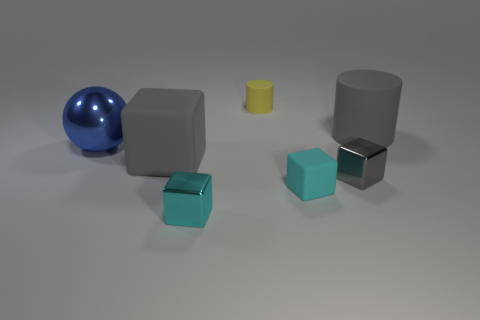There is a large matte object in front of the blue sphere; is it the same color as the small metallic block that is behind the small cyan metallic block?
Provide a succinct answer. Yes. Is the number of cubes in front of the tiny cyan metal block less than the number of small blocks that are in front of the tiny gray metal object?
Ensure brevity in your answer.  Yes. The small cyan thing that is right of the tiny cyan metallic object has what shape?
Keep it short and to the point. Cube. What is the material of the other cube that is the same color as the tiny rubber cube?
Your answer should be very brief. Metal. How many other things are made of the same material as the big gray cube?
Your answer should be very brief. 3. There is a big blue metallic object; is its shape the same as the cyan object that is on the right side of the small yellow object?
Offer a terse response. No. What is the shape of the big thing that is the same material as the tiny gray cube?
Keep it short and to the point. Sphere. Is the number of cylinders on the left side of the small cyan rubber thing greater than the number of small cyan metal cubes that are in front of the yellow object?
Give a very brief answer. No. How many things are big blue things or tiny cyan cubes?
Ensure brevity in your answer.  3. How many other things are the same color as the small rubber cylinder?
Offer a very short reply. 0. 